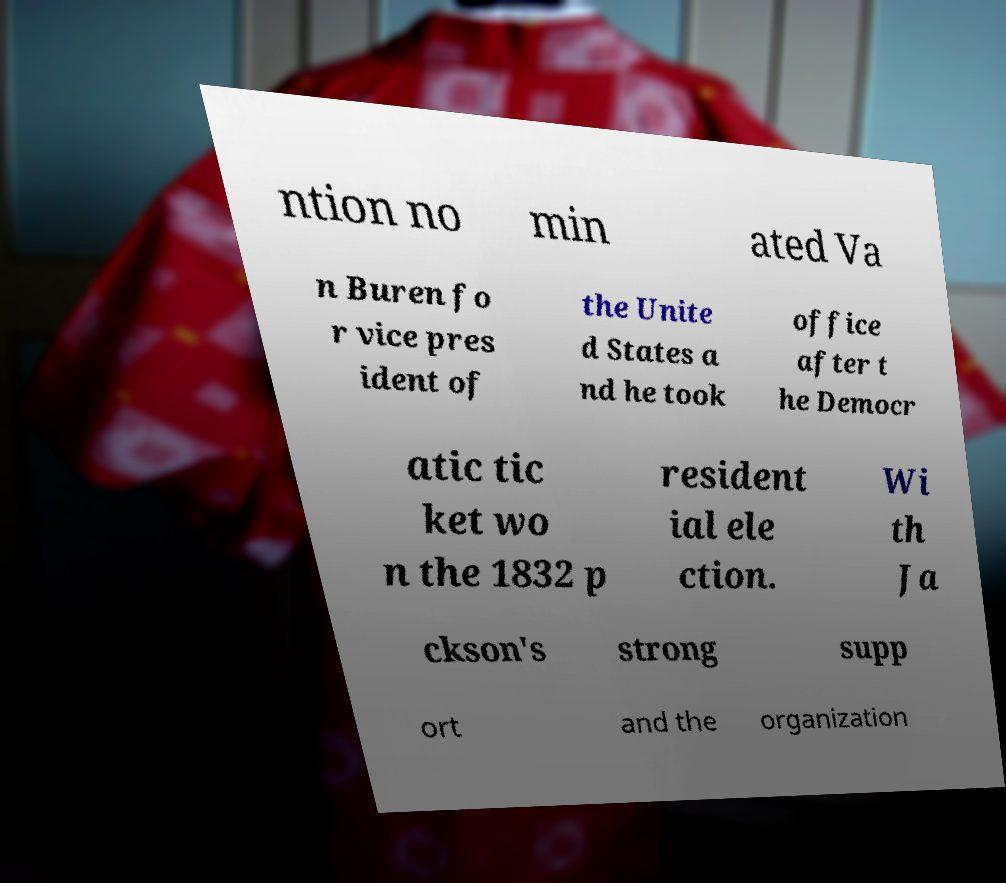I need the written content from this picture converted into text. Can you do that? ntion no min ated Va n Buren fo r vice pres ident of the Unite d States a nd he took office after t he Democr atic tic ket wo n the 1832 p resident ial ele ction. Wi th Ja ckson's strong supp ort and the organization 